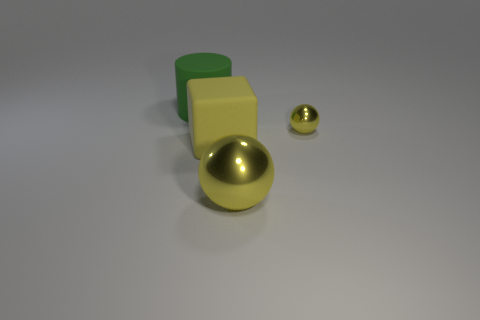Add 4 large yellow cylinders. How many objects exist? 8 Add 4 yellow rubber blocks. How many yellow rubber blocks are left? 5 Add 4 small brown metal cubes. How many small brown metal cubes exist? 4 Subtract 1 yellow cubes. How many objects are left? 3 Subtract all cylinders. How many objects are left? 3 Subtract all green balls. Subtract all green cylinders. How many balls are left? 2 Subtract all gray matte cylinders. Subtract all blocks. How many objects are left? 3 